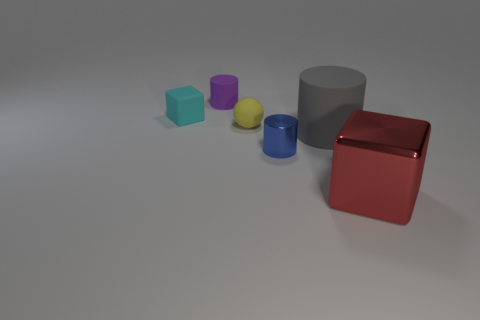Subtract all balls. How many objects are left? 5 Subtract 3 cylinders. How many cylinders are left? 0 Subtract all purple blocks. Subtract all gray spheres. How many blocks are left? 2 Subtract all gray cylinders. How many cyan cubes are left? 1 Subtract all tiny cyan blocks. Subtract all blocks. How many objects are left? 3 Add 3 large gray cylinders. How many large gray cylinders are left? 4 Add 1 metal blocks. How many metal blocks exist? 2 Add 3 large red blocks. How many objects exist? 9 Subtract all red blocks. How many blocks are left? 1 Subtract all big cylinders. How many cylinders are left? 2 